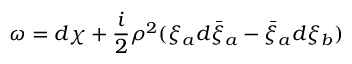Convert formula to latex. <formula><loc_0><loc_0><loc_500><loc_500>\omega = d \chi + \frac { i } { 2 } \rho ^ { 2 } ( \xi _ { a } d \bar { \xi } _ { a } - \bar { \xi } _ { a } d \xi _ { b } )</formula> 